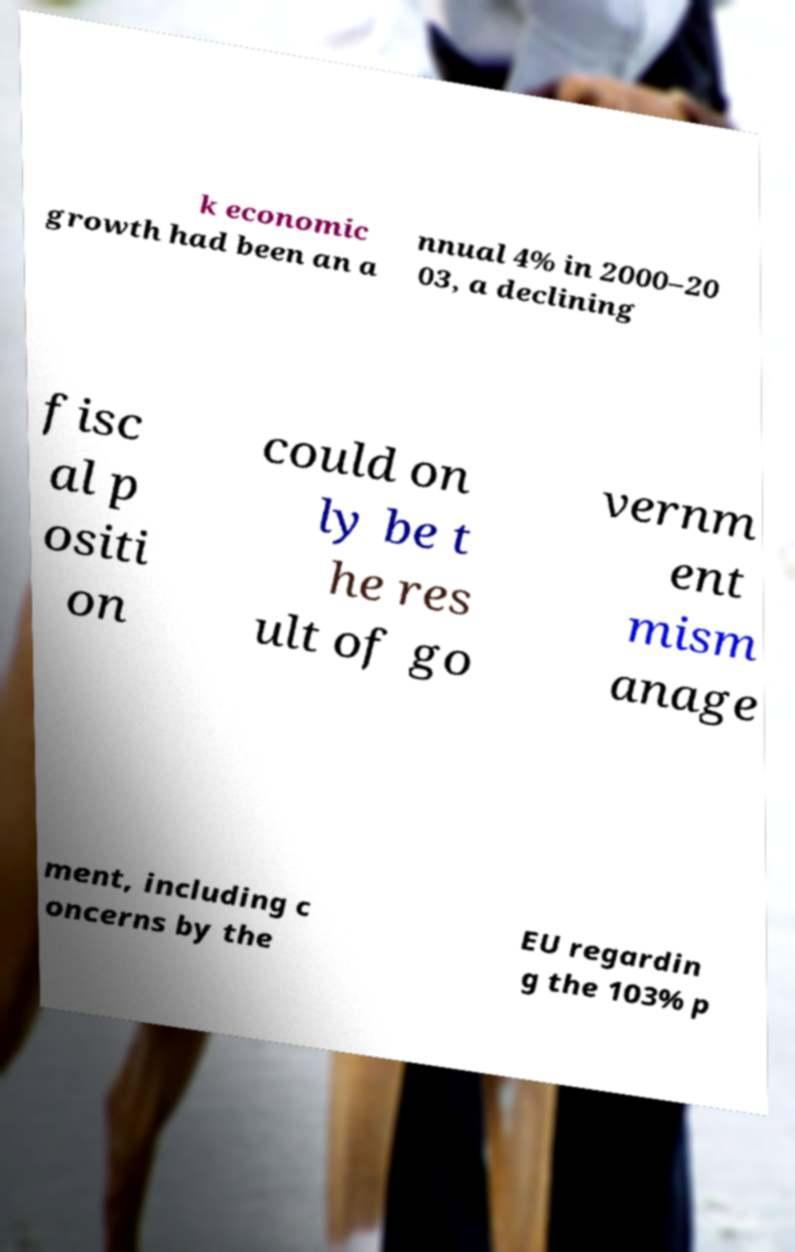Please read and relay the text visible in this image. What does it say? k economic growth had been an a nnual 4% in 2000–20 03, a declining fisc al p ositi on could on ly be t he res ult of go vernm ent mism anage ment, including c oncerns by the EU regardin g the 103% p 